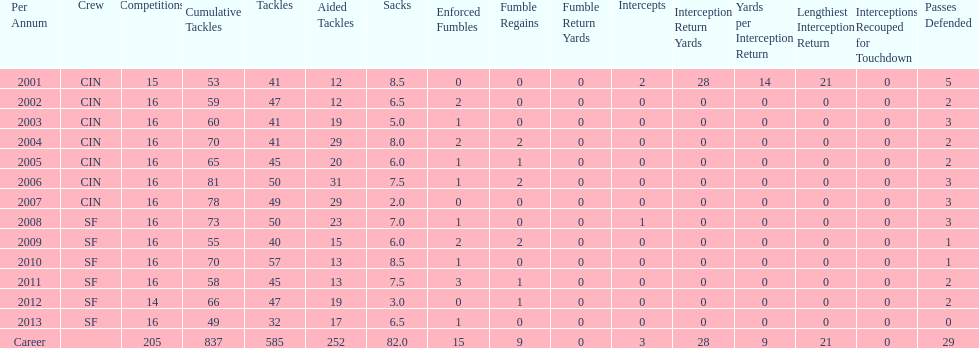How many consecutive years were there 20 or more assisted tackles? 5. Parse the full table. {'header': ['Per Annum', 'Crew', 'Competitions', 'Cumulative Tackles', 'Tackles', 'Aided Tackles', 'Sacks', 'Enforced Fumbles', 'Fumble Regains', 'Fumble Return Yards', 'Intercepts', 'Interception Return Yards', 'Yards per Interception Return', 'Lengthiest Interception Return', 'Interceptions Recouped for Touchdown', 'Passes Defended'], 'rows': [['2001', 'CIN', '15', '53', '41', '12', '8.5', '0', '0', '0', '2', '28', '14', '21', '0', '5'], ['2002', 'CIN', '16', '59', '47', '12', '6.5', '2', '0', '0', '0', '0', '0', '0', '0', '2'], ['2003', 'CIN', '16', '60', '41', '19', '5.0', '1', '0', '0', '0', '0', '0', '0', '0', '3'], ['2004', 'CIN', '16', '70', '41', '29', '8.0', '2', '2', '0', '0', '0', '0', '0', '0', '2'], ['2005', 'CIN', '16', '65', '45', '20', '6.0', '1', '1', '0', '0', '0', '0', '0', '0', '2'], ['2006', 'CIN', '16', '81', '50', '31', '7.5', '1', '2', '0', '0', '0', '0', '0', '0', '3'], ['2007', 'CIN', '16', '78', '49', '29', '2.0', '0', '0', '0', '0', '0', '0', '0', '0', '3'], ['2008', 'SF', '16', '73', '50', '23', '7.0', '1', '0', '0', '1', '0', '0', '0', '0', '3'], ['2009', 'SF', '16', '55', '40', '15', '6.0', '2', '2', '0', '0', '0', '0', '0', '0', '1'], ['2010', 'SF', '16', '70', '57', '13', '8.5', '1', '0', '0', '0', '0', '0', '0', '0', '1'], ['2011', 'SF', '16', '58', '45', '13', '7.5', '3', '1', '0', '0', '0', '0', '0', '0', '2'], ['2012', 'SF', '14', '66', '47', '19', '3.0', '0', '1', '0', '0', '0', '0', '0', '0', '2'], ['2013', 'SF', '16', '49', '32', '17', '6.5', '1', '0', '0', '0', '0', '0', '0', '0', '0'], ['Career', '', '205', '837', '585', '252', '82.0', '15', '9', '0', '3', '28', '9', '21', '0', '29']]} 